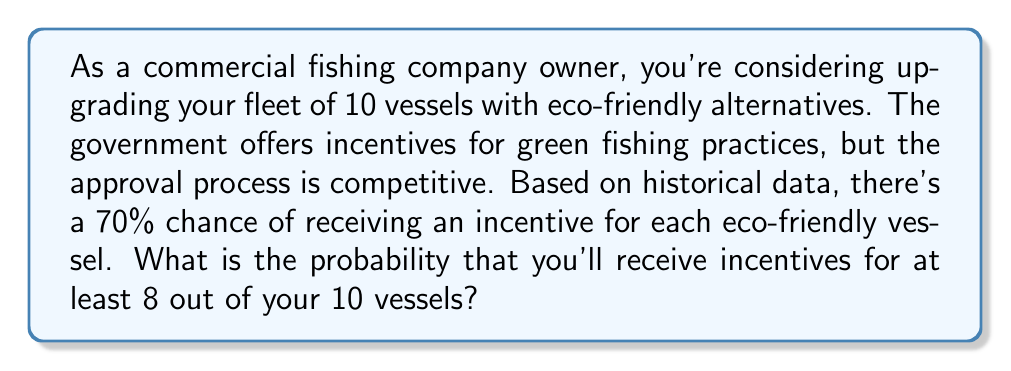Help me with this question. To solve this problem, we need to use the binomial probability distribution. Let's break it down step-by-step:

1) We have a binomial distribution with the following parameters:
   $n = 10$ (number of trials/vessels)
   $p = 0.70$ (probability of success for each trial)
   $q = 1 - p = 0.30$ (probability of failure for each trial)

2) We want to find the probability of at least 8 successes. This means we need to calculate the probability of 8, 9, or 10 successes and sum them up.

3) The binomial probability formula is:

   $P(X = k) = \binom{n}{k} p^k q^{n-k}$

   Where $\binom{n}{k}$ is the binomial coefficient, calculated as:

   $\binom{n}{k} = \frac{n!}{k!(n-k)!}$

4) Let's calculate the probabilities for 8, 9, and 10 successes:

   For 8 successes:
   $P(X = 8) = \binom{10}{8} (0.70)^8 (0.30)^2 = 45 \times 0.05764801 \times 0.09 = 0.233774$

   For 9 successes:
   $P(X = 9) = \binom{10}{9} (0.70)^9 (0.30)^1 = 10 \times 0.04035361 \times 0.30 = 0.121061$

   For 10 successes:
   $P(X = 10) = \binom{10}{10} (0.70)^{10} (0.30)^0 = 1 \times 0.02824752 \times 1 = 0.028248$

5) The probability of at least 8 successes is the sum of these probabilities:

   $P(X \geq 8) = P(X = 8) + P(X = 9) + P(X = 10)$
   $= 0.233774 + 0.121061 + 0.028248 = 0.383083$

Therefore, the probability of receiving incentives for at least 8 out of 10 vessels is approximately 0.383083 or 38.31%.
Answer: $P(X \geq 8) \approx 0.383083$ or 38.31% 